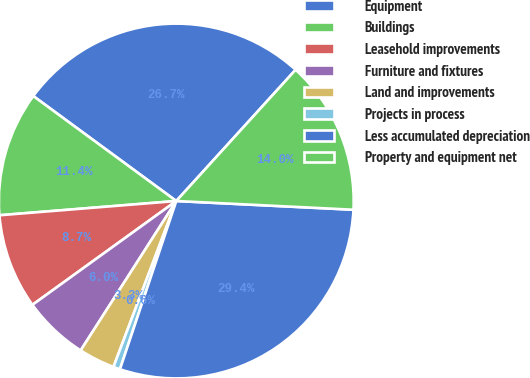<chart> <loc_0><loc_0><loc_500><loc_500><pie_chart><fcel>Equipment<fcel>Buildings<fcel>Leasehold improvements<fcel>Furniture and fixtures<fcel>Land and improvements<fcel>Projects in process<fcel>Less accumulated depreciation<fcel>Property and equipment net<nl><fcel>26.67%<fcel>11.36%<fcel>8.67%<fcel>5.99%<fcel>3.3%<fcel>0.62%<fcel>29.36%<fcel>14.04%<nl></chart> 